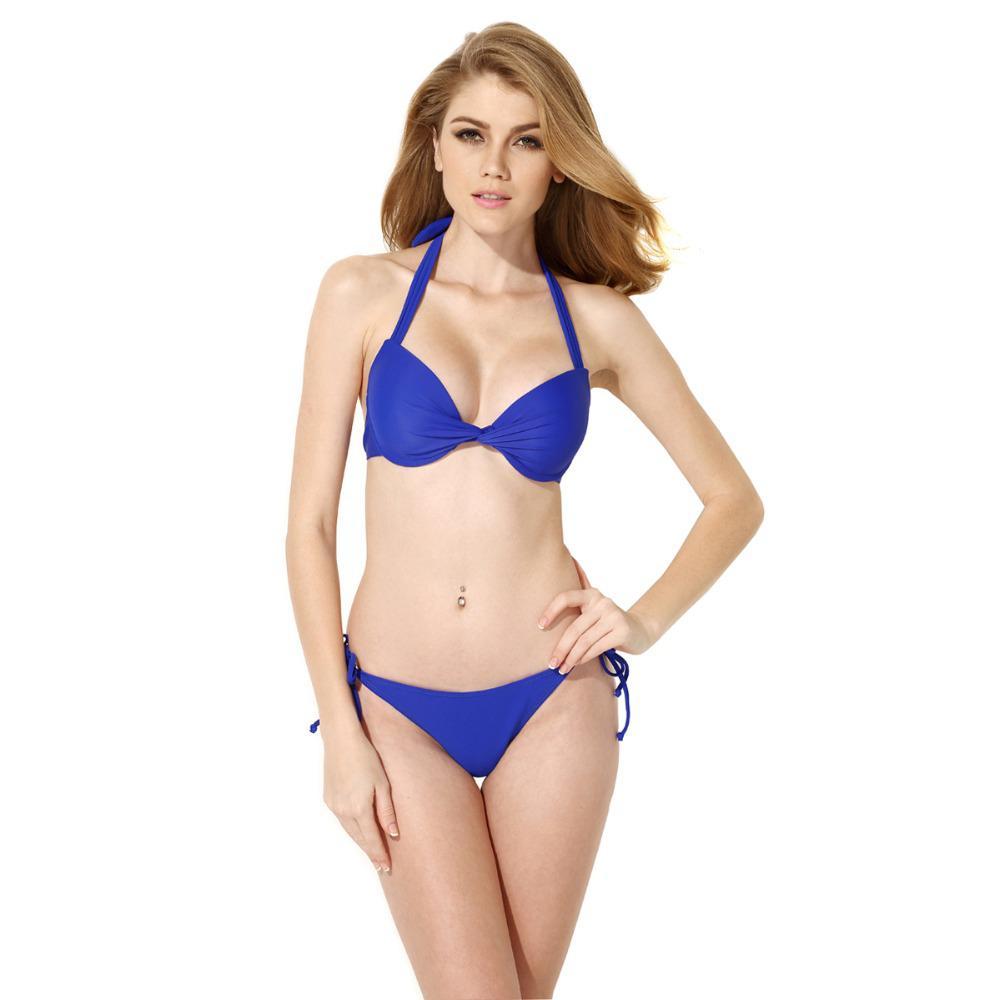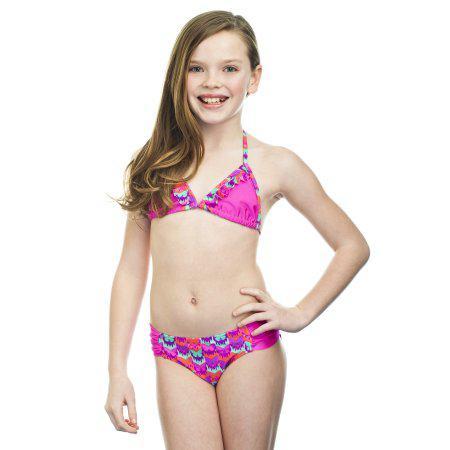The first image is the image on the left, the second image is the image on the right. Examine the images to the left and right. Is the description "At least one of the bikini models pictured is a child." accurate? Answer yes or no. Yes. 